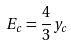Convert formula to latex. <formula><loc_0><loc_0><loc_500><loc_500>E _ { c } = \frac { 4 } { 3 } y _ { c }</formula> 